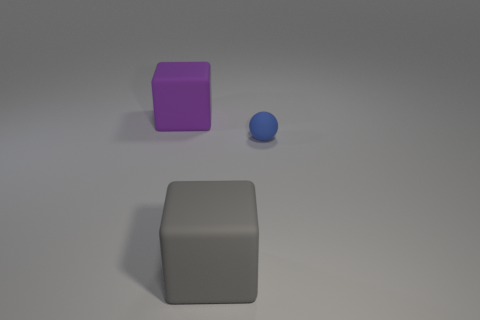There is a purple rubber object that is behind the blue object; does it have the same shape as the gray rubber thing?
Offer a terse response. Yes. What number of gray objects are either spheres or large rubber cubes?
Offer a terse response. 1. What number of other objects are the same shape as the tiny blue matte object?
Your response must be concise. 0. What shape is the object that is both behind the big gray matte cube and on the left side of the tiny object?
Provide a succinct answer. Cube. Are there any matte things behind the big gray rubber cube?
Give a very brief answer. Yes. There is another matte thing that is the same shape as the gray rubber thing; what is its size?
Ensure brevity in your answer.  Large. Is there anything else that is the same size as the gray matte block?
Provide a succinct answer. Yes. Does the gray rubber object have the same shape as the purple thing?
Provide a short and direct response. Yes. There is a rubber cube left of the big rubber block in front of the blue sphere; what is its size?
Give a very brief answer. Large. What is the color of the other large matte object that is the same shape as the big purple matte object?
Give a very brief answer. Gray. 